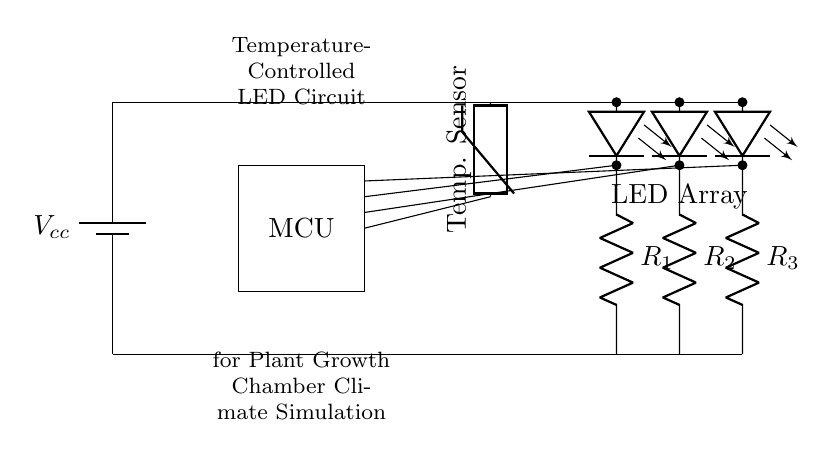What type of components are included in the circuit? The circuit contains a battery, microcontroller, temperature sensor, LED array, and resistors. These components are visible in the schematic diagram, and each is crucial for the function of the circuit.
Answer: battery, microcontroller, temperature sensor, LED array, resistors How many LEDs are present in the circuit? The circuit includes three LEDs, as indicated by three leDo symbols connected in series from the LED array. Each LED symbol represents a single LED in the configuration shown.
Answer: three What is the function of the microcontroller in this circuit? The microcontroller (MCU) processes data from the temperature sensor to control the LED array based on temperature readings. Its role is crucial for automating the climate simulation in the plant growth chamber.
Answer: control What is the relationship between the temperature sensor and the microcontroller? The temperature sensor provides input to the microcontroller, which uses this input to make decisions about the LED array's operation. This relationship is foundational for dynamic adjustments in response to temperature changes.
Answer: input/output What does the resistor connected to each LED do? The resistors (R1, R2, R3) limit the current flowing through the respective LEDs, preventing them from burning out. This is a common practice in LED circuits to ensure safe operation within specified current limits.
Answer: limit current How does the circuit achieve temperature control for plant growth simulations? The circuit achieves temperature control by using the temperature sensor to monitor the environment and the microcontroller to adjust the intensity of the LED array based on real-time temperature data. This feedback loop enables precise climate control.
Answer: feedback loop What is the voltage source in the circuit? The voltage source in the circuit is represented by the battery symbol labeled Vcc, which provides the necessary power for the operation of the entire circuit components.
Answer: Vcc 